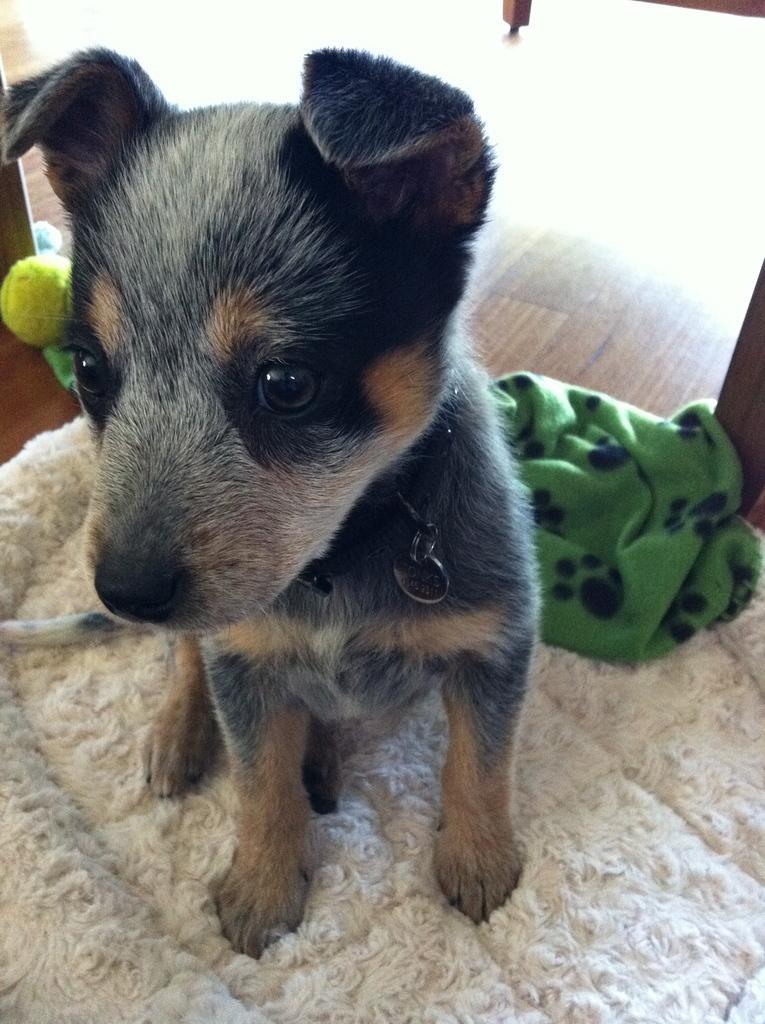Can you describe this image briefly? In the center of the image there is a dog on the mat. In the background we can see cloth, ball and floor. 